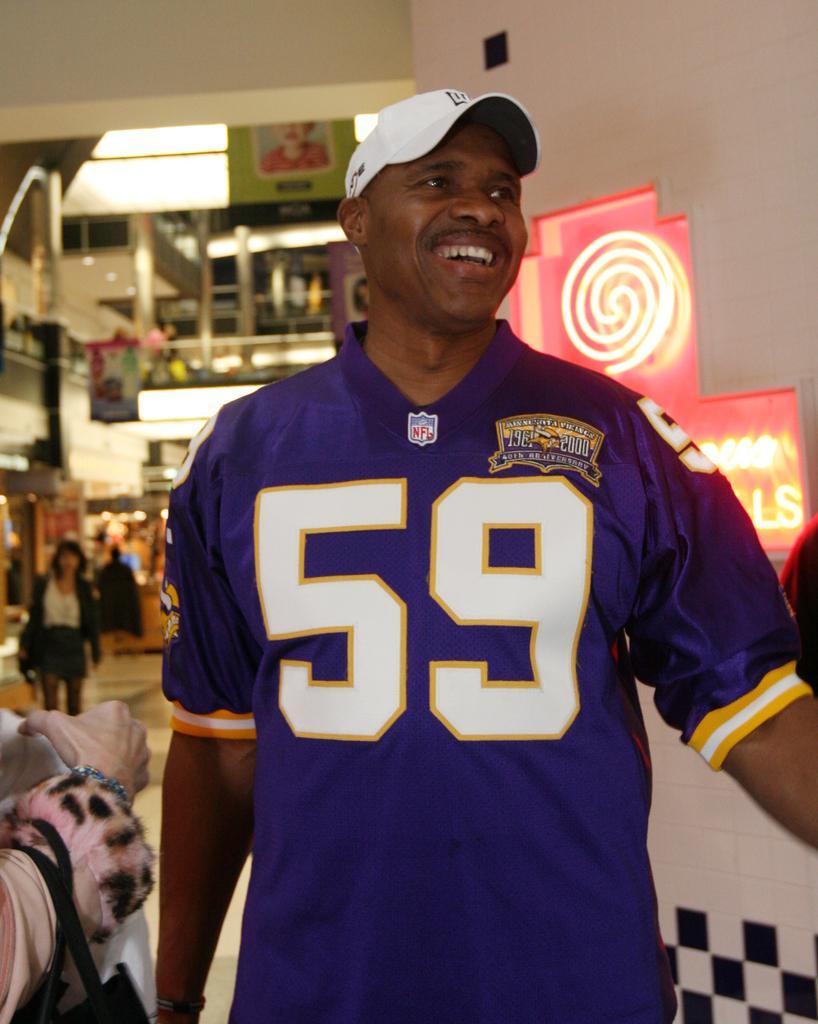How would you summarize this image in a sentence or two? In the picture we can see a man standing and he is with blue T-shirt and number 59 on it and he is with white color cap and smiling and beside him we can see a person hand and behind him we can see some people are walking and some shops behind them. 